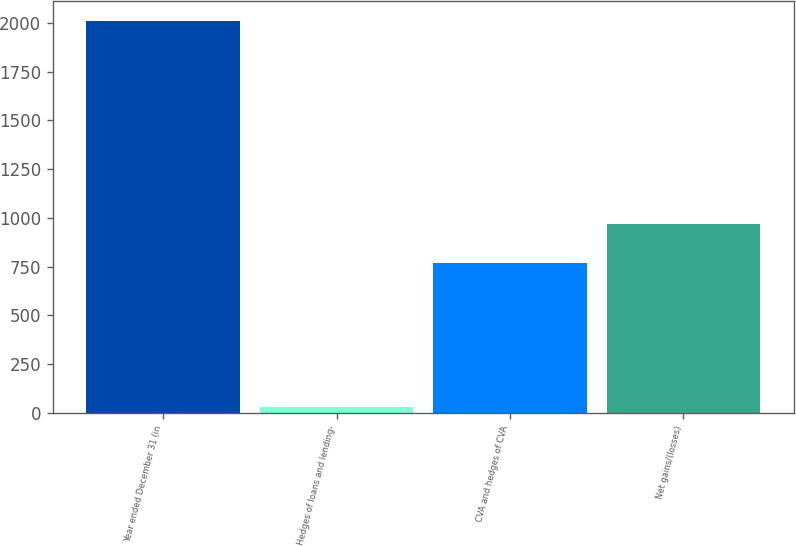Convert chart to OTSL. <chart><loc_0><loc_0><loc_500><loc_500><bar_chart><fcel>Year ended December 31 (in<fcel>Hedges of loans and lending-<fcel>CVA and hedges of CVA<fcel>Net gains/(losses)<nl><fcel>2011<fcel>32<fcel>769<fcel>966.9<nl></chart> 